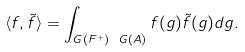Convert formula to latex. <formula><loc_0><loc_0><loc_500><loc_500>\langle f , \tilde { f } \rangle = \int _ { G ( F ^ { + } ) \ G ( { A } ) } f ( g ) \tilde { f } ( g ) d g .</formula> 